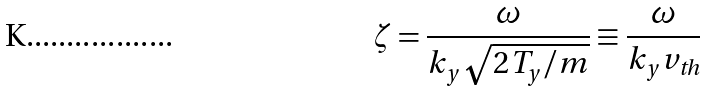Convert formula to latex. <formula><loc_0><loc_0><loc_500><loc_500>\zeta = \frac { \omega } { k _ { y } \sqrt { 2 T _ { y } / m } } \equiv \frac { \omega } { k _ { y } v _ { \text {th} } }</formula> 